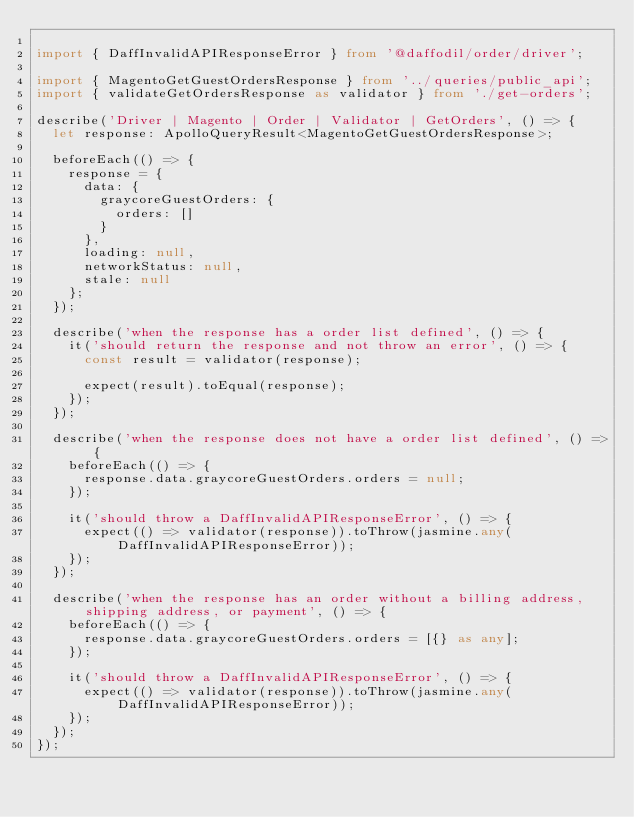Convert code to text. <code><loc_0><loc_0><loc_500><loc_500><_TypeScript_>
import { DaffInvalidAPIResponseError } from '@daffodil/order/driver';

import { MagentoGetGuestOrdersResponse } from '../queries/public_api';
import { validateGetOrdersResponse as validator } from './get-orders';

describe('Driver | Magento | Order | Validator | GetOrders', () => {
  let response: ApolloQueryResult<MagentoGetGuestOrdersResponse>;

  beforeEach(() => {
    response = {
      data: {
        graycoreGuestOrders: {
          orders: []
        }
      },
      loading: null,
      networkStatus: null,
      stale: null
    };
  });

  describe('when the response has a order list defined', () => {
    it('should return the response and not throw an error', () => {
      const result = validator(response);

      expect(result).toEqual(response);
    });
  });

  describe('when the response does not have a order list defined', () => {
    beforeEach(() => {
      response.data.graycoreGuestOrders.orders = null;
    });

    it('should throw a DaffInvalidAPIResponseError', () => {
      expect(() => validator(response)).toThrow(jasmine.any(DaffInvalidAPIResponseError));
    });
  });

  describe('when the response has an order without a billing address, shipping address, or payment', () => {
    beforeEach(() => {
      response.data.graycoreGuestOrders.orders = [{} as any];
    });

    it('should throw a DaffInvalidAPIResponseError', () => {
      expect(() => validator(response)).toThrow(jasmine.any(DaffInvalidAPIResponseError));
    });
  });
});
</code> 